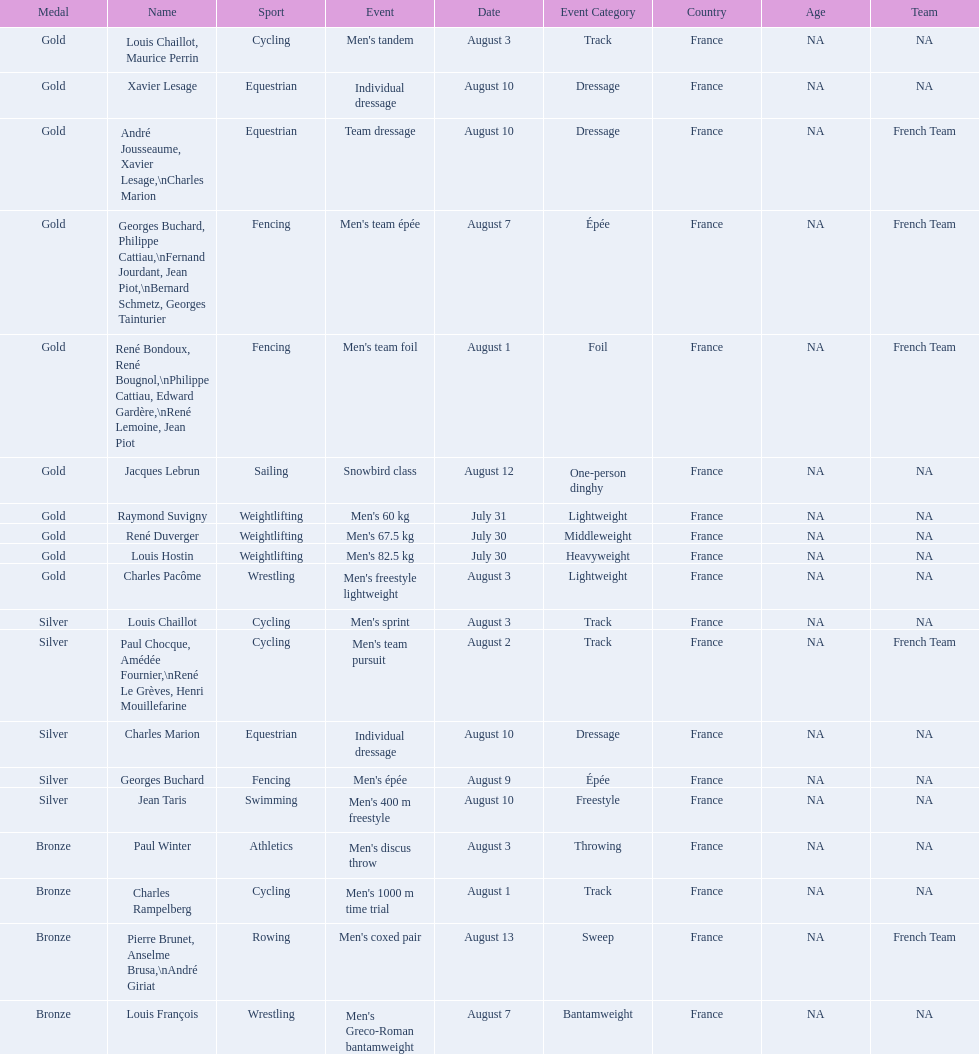What sport is listed first? Cycling. 